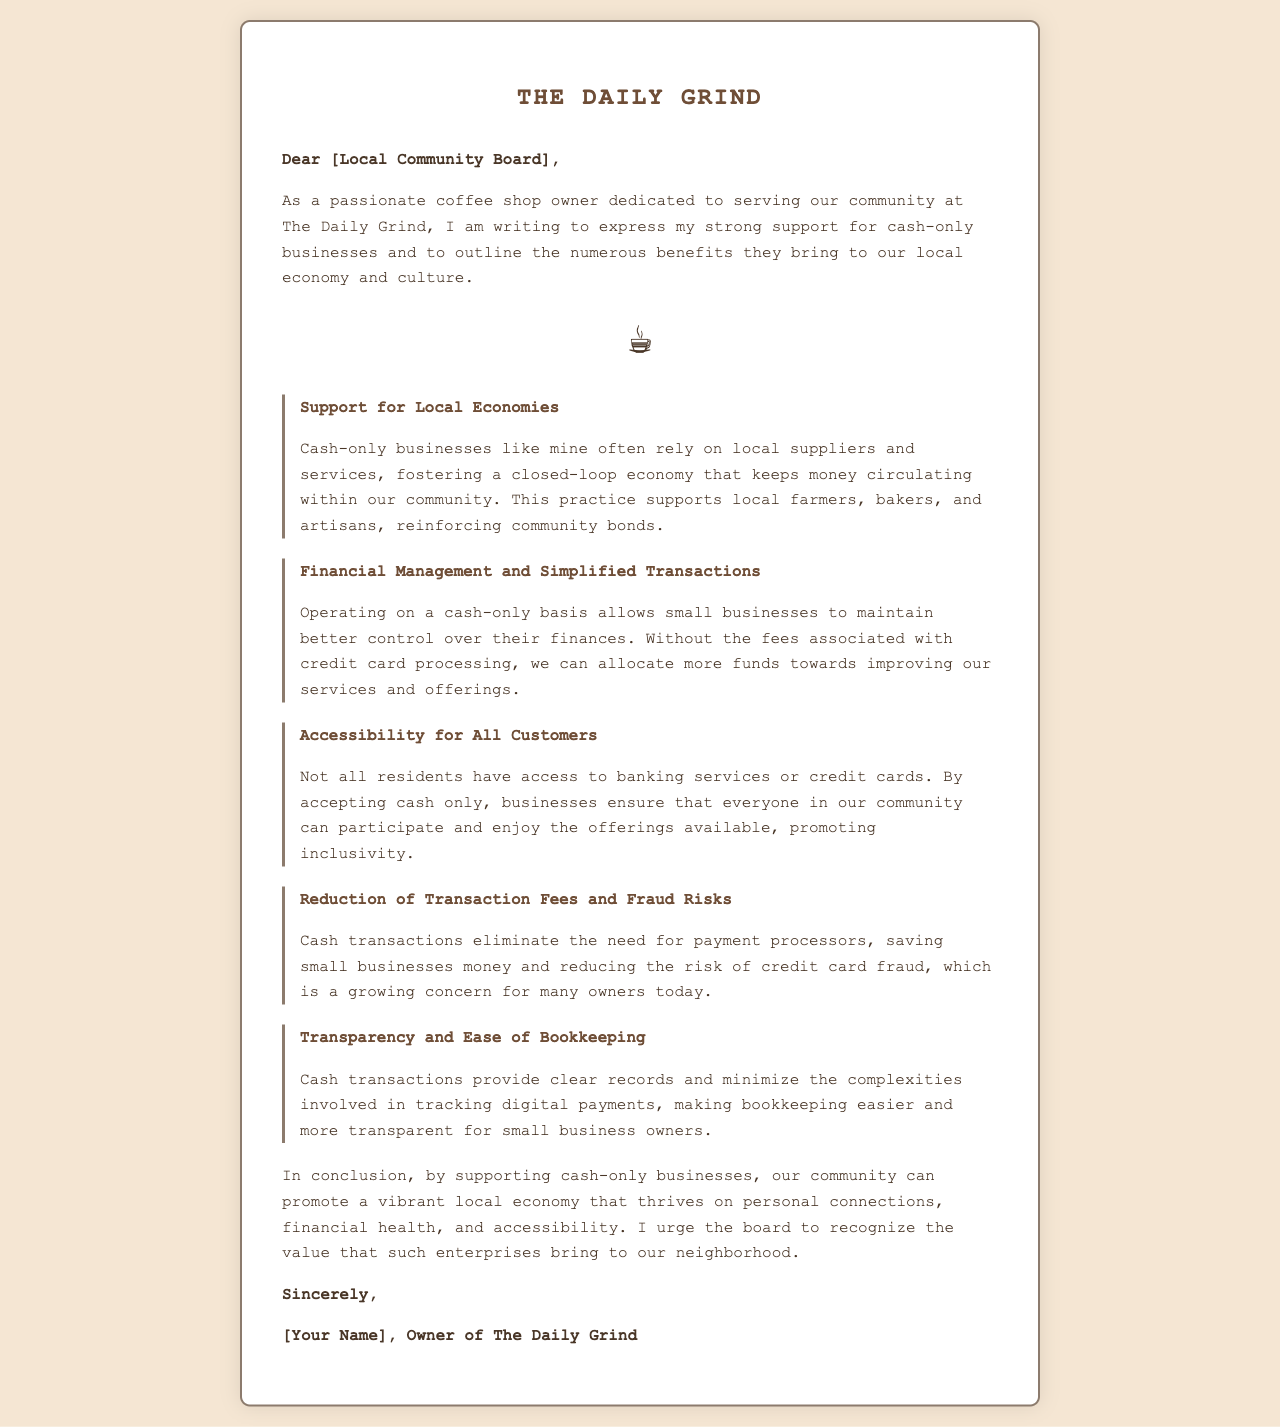What is the name of the coffee shop? The coffee shop is referred to as "The Daily Grind" in the document.
Answer: The Daily Grind Who is the author of the letter? The author's name is mentioned at the end of the letter, following the signature line.
Answer: [Your Name] What is one benefit of cash-only businesses? The document lists several benefits, one of them is directly mentioned in the section titled "Support for Local Economies."
Answer: Support for Local Economies How do cash-only businesses help with financial management? The letter states that operating on a cash-only basis allows for better financial control, as mentioned in the second benefit section.
Answer: Financial Management and Simplified Transactions What is a reason given for promoting inclusivity? The document explains that not all residents have access to banking services, encouraging cash-only business practices for accessibility.
Answer: Accessibility for All Customers What risk does accepting only cash help to reduce? The benefits section mentions that cash transactions reduce the risk of credit card fraud.
Answer: Fraud Risks What is the closing statement of the letter? The closing statement used by the author is found just before the signature at the end of the document.
Answer: Sincerely What type of document is this? The structure and content indicate that this is a letter addressed to a local community board.
Answer: Letter 